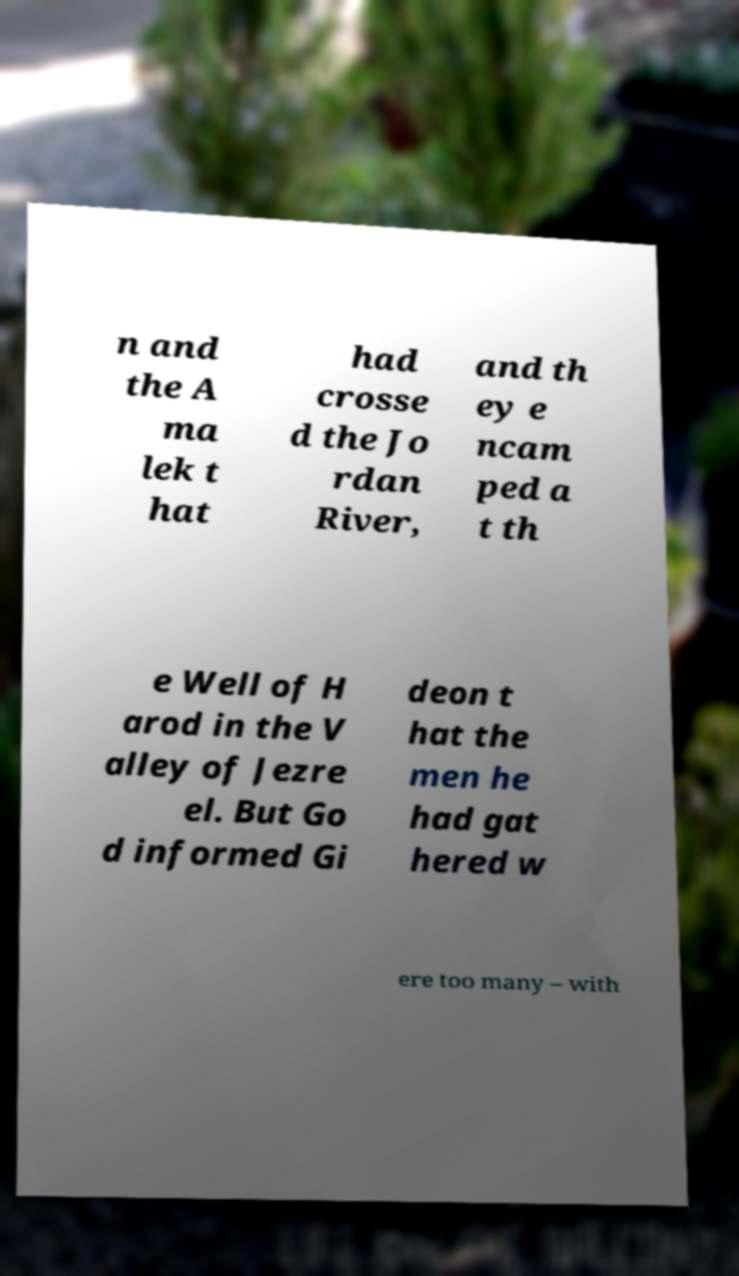For documentation purposes, I need the text within this image transcribed. Could you provide that? n and the A ma lek t hat had crosse d the Jo rdan River, and th ey e ncam ped a t th e Well of H arod in the V alley of Jezre el. But Go d informed Gi deon t hat the men he had gat hered w ere too many – with 